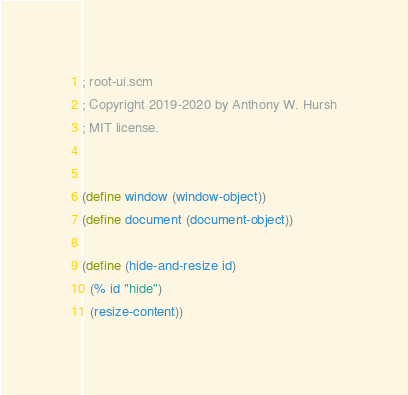<code> <loc_0><loc_0><loc_500><loc_500><_Scheme_>; root-ui.scm
; Copyright 2019-2020 by Anthony W. Hursh
; MIT license.


(define window (window-object))
(define document (document-object))

(define (hide-and-resize id)
  (% id "hide")
  (resize-content))
</code> 